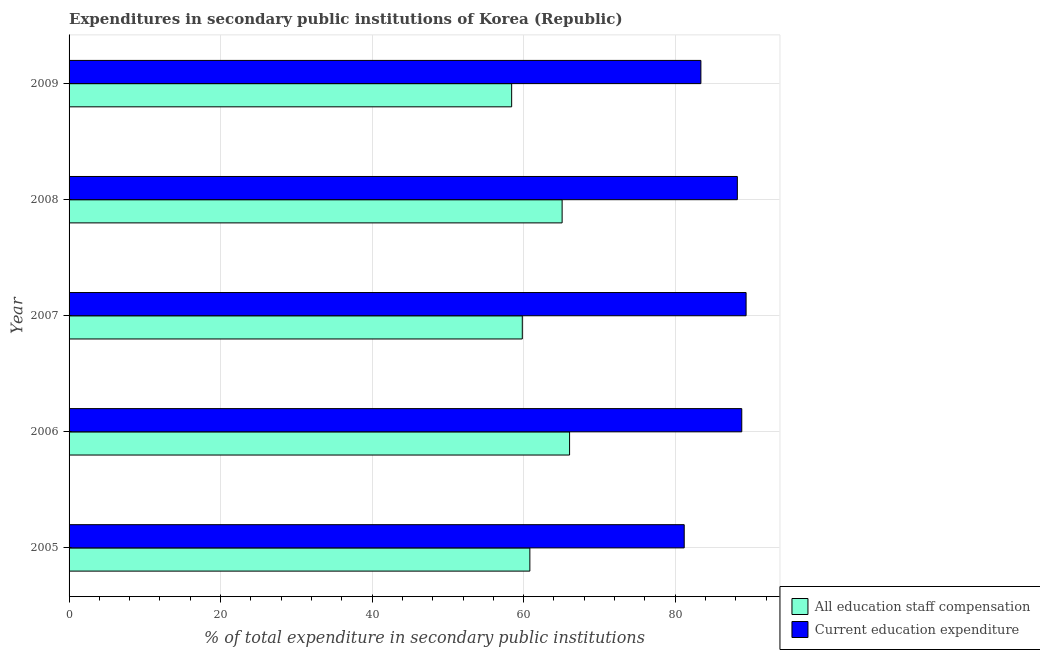Are the number of bars on each tick of the Y-axis equal?
Make the answer very short. Yes. How many bars are there on the 4th tick from the top?
Make the answer very short. 2. How many bars are there on the 1st tick from the bottom?
Your answer should be compact. 2. What is the label of the 5th group of bars from the top?
Provide a succinct answer. 2005. What is the expenditure in education in 2008?
Your answer should be very brief. 88.2. Across all years, what is the maximum expenditure in staff compensation?
Give a very brief answer. 66.06. Across all years, what is the minimum expenditure in education?
Your response must be concise. 81.19. What is the total expenditure in staff compensation in the graph?
Offer a terse response. 310.19. What is the difference between the expenditure in education in 2007 and that in 2008?
Your response must be concise. 1.15. What is the difference between the expenditure in education in 2008 and the expenditure in staff compensation in 2009?
Give a very brief answer. 29.79. What is the average expenditure in staff compensation per year?
Your answer should be very brief. 62.04. In the year 2009, what is the difference between the expenditure in staff compensation and expenditure in education?
Provide a short and direct response. -24.98. In how many years, is the expenditure in education greater than 32 %?
Provide a succinct answer. 5. What is the ratio of the expenditure in education in 2008 to that in 2009?
Keep it short and to the point. 1.06. Is the expenditure in education in 2005 less than that in 2006?
Provide a short and direct response. Yes. Is the difference between the expenditure in education in 2007 and 2009 greater than the difference between the expenditure in staff compensation in 2007 and 2009?
Give a very brief answer. Yes. What is the difference between the highest and the lowest expenditure in education?
Ensure brevity in your answer.  8.17. What does the 1st bar from the top in 2008 represents?
Offer a terse response. Current education expenditure. What does the 1st bar from the bottom in 2005 represents?
Offer a very short reply. All education staff compensation. How many bars are there?
Offer a terse response. 10. Are all the bars in the graph horizontal?
Provide a succinct answer. Yes. What is the difference between two consecutive major ticks on the X-axis?
Your answer should be very brief. 20. Does the graph contain any zero values?
Offer a terse response. No. Where does the legend appear in the graph?
Offer a terse response. Bottom right. What is the title of the graph?
Provide a short and direct response. Expenditures in secondary public institutions of Korea (Republic). What is the label or title of the X-axis?
Provide a short and direct response. % of total expenditure in secondary public institutions. What is the % of total expenditure in secondary public institutions of All education staff compensation in 2005?
Give a very brief answer. 60.82. What is the % of total expenditure in secondary public institutions in Current education expenditure in 2005?
Ensure brevity in your answer.  81.19. What is the % of total expenditure in secondary public institutions of All education staff compensation in 2006?
Ensure brevity in your answer.  66.06. What is the % of total expenditure in secondary public institutions of Current education expenditure in 2006?
Your response must be concise. 88.79. What is the % of total expenditure in secondary public institutions in All education staff compensation in 2007?
Your response must be concise. 59.82. What is the % of total expenditure in secondary public institutions in Current education expenditure in 2007?
Ensure brevity in your answer.  89.36. What is the % of total expenditure in secondary public institutions of All education staff compensation in 2008?
Offer a very short reply. 65.08. What is the % of total expenditure in secondary public institutions of Current education expenditure in 2008?
Provide a short and direct response. 88.2. What is the % of total expenditure in secondary public institutions in All education staff compensation in 2009?
Offer a very short reply. 58.42. What is the % of total expenditure in secondary public institutions in Current education expenditure in 2009?
Your response must be concise. 83.39. Across all years, what is the maximum % of total expenditure in secondary public institutions in All education staff compensation?
Provide a short and direct response. 66.06. Across all years, what is the maximum % of total expenditure in secondary public institutions in Current education expenditure?
Your answer should be compact. 89.36. Across all years, what is the minimum % of total expenditure in secondary public institutions of All education staff compensation?
Give a very brief answer. 58.42. Across all years, what is the minimum % of total expenditure in secondary public institutions in Current education expenditure?
Provide a short and direct response. 81.19. What is the total % of total expenditure in secondary public institutions in All education staff compensation in the graph?
Your answer should be compact. 310.19. What is the total % of total expenditure in secondary public institutions of Current education expenditure in the graph?
Offer a terse response. 430.93. What is the difference between the % of total expenditure in secondary public institutions of All education staff compensation in 2005 and that in 2006?
Keep it short and to the point. -5.24. What is the difference between the % of total expenditure in secondary public institutions in Current education expenditure in 2005 and that in 2006?
Ensure brevity in your answer.  -7.6. What is the difference between the % of total expenditure in secondary public institutions in All education staff compensation in 2005 and that in 2007?
Provide a short and direct response. 1. What is the difference between the % of total expenditure in secondary public institutions in Current education expenditure in 2005 and that in 2007?
Offer a terse response. -8.17. What is the difference between the % of total expenditure in secondary public institutions of All education staff compensation in 2005 and that in 2008?
Ensure brevity in your answer.  -4.26. What is the difference between the % of total expenditure in secondary public institutions in Current education expenditure in 2005 and that in 2008?
Make the answer very short. -7.01. What is the difference between the % of total expenditure in secondary public institutions in All education staff compensation in 2005 and that in 2009?
Offer a terse response. 2.4. What is the difference between the % of total expenditure in secondary public institutions in Current education expenditure in 2005 and that in 2009?
Your answer should be compact. -2.2. What is the difference between the % of total expenditure in secondary public institutions in All education staff compensation in 2006 and that in 2007?
Your answer should be compact. 6.24. What is the difference between the % of total expenditure in secondary public institutions in Current education expenditure in 2006 and that in 2007?
Provide a succinct answer. -0.57. What is the difference between the % of total expenditure in secondary public institutions of All education staff compensation in 2006 and that in 2008?
Offer a terse response. 0.98. What is the difference between the % of total expenditure in secondary public institutions in Current education expenditure in 2006 and that in 2008?
Provide a succinct answer. 0.58. What is the difference between the % of total expenditure in secondary public institutions of All education staff compensation in 2006 and that in 2009?
Your answer should be compact. 7.64. What is the difference between the % of total expenditure in secondary public institutions of Current education expenditure in 2006 and that in 2009?
Your answer should be compact. 5.4. What is the difference between the % of total expenditure in secondary public institutions in All education staff compensation in 2007 and that in 2008?
Make the answer very short. -5.26. What is the difference between the % of total expenditure in secondary public institutions in Current education expenditure in 2007 and that in 2008?
Ensure brevity in your answer.  1.15. What is the difference between the % of total expenditure in secondary public institutions in All education staff compensation in 2007 and that in 2009?
Keep it short and to the point. 1.4. What is the difference between the % of total expenditure in secondary public institutions of Current education expenditure in 2007 and that in 2009?
Ensure brevity in your answer.  5.97. What is the difference between the % of total expenditure in secondary public institutions in All education staff compensation in 2008 and that in 2009?
Offer a terse response. 6.66. What is the difference between the % of total expenditure in secondary public institutions in Current education expenditure in 2008 and that in 2009?
Ensure brevity in your answer.  4.81. What is the difference between the % of total expenditure in secondary public institutions in All education staff compensation in 2005 and the % of total expenditure in secondary public institutions in Current education expenditure in 2006?
Provide a short and direct response. -27.97. What is the difference between the % of total expenditure in secondary public institutions in All education staff compensation in 2005 and the % of total expenditure in secondary public institutions in Current education expenditure in 2007?
Offer a very short reply. -28.54. What is the difference between the % of total expenditure in secondary public institutions in All education staff compensation in 2005 and the % of total expenditure in secondary public institutions in Current education expenditure in 2008?
Make the answer very short. -27.39. What is the difference between the % of total expenditure in secondary public institutions of All education staff compensation in 2005 and the % of total expenditure in secondary public institutions of Current education expenditure in 2009?
Offer a terse response. -22.57. What is the difference between the % of total expenditure in secondary public institutions of All education staff compensation in 2006 and the % of total expenditure in secondary public institutions of Current education expenditure in 2007?
Your answer should be very brief. -23.3. What is the difference between the % of total expenditure in secondary public institutions of All education staff compensation in 2006 and the % of total expenditure in secondary public institutions of Current education expenditure in 2008?
Offer a very short reply. -22.14. What is the difference between the % of total expenditure in secondary public institutions in All education staff compensation in 2006 and the % of total expenditure in secondary public institutions in Current education expenditure in 2009?
Your answer should be compact. -17.33. What is the difference between the % of total expenditure in secondary public institutions of All education staff compensation in 2007 and the % of total expenditure in secondary public institutions of Current education expenditure in 2008?
Provide a succinct answer. -28.38. What is the difference between the % of total expenditure in secondary public institutions in All education staff compensation in 2007 and the % of total expenditure in secondary public institutions in Current education expenditure in 2009?
Make the answer very short. -23.57. What is the difference between the % of total expenditure in secondary public institutions of All education staff compensation in 2008 and the % of total expenditure in secondary public institutions of Current education expenditure in 2009?
Make the answer very short. -18.32. What is the average % of total expenditure in secondary public institutions of All education staff compensation per year?
Your answer should be compact. 62.04. What is the average % of total expenditure in secondary public institutions of Current education expenditure per year?
Your response must be concise. 86.19. In the year 2005, what is the difference between the % of total expenditure in secondary public institutions in All education staff compensation and % of total expenditure in secondary public institutions in Current education expenditure?
Your response must be concise. -20.37. In the year 2006, what is the difference between the % of total expenditure in secondary public institutions of All education staff compensation and % of total expenditure in secondary public institutions of Current education expenditure?
Provide a short and direct response. -22.73. In the year 2007, what is the difference between the % of total expenditure in secondary public institutions in All education staff compensation and % of total expenditure in secondary public institutions in Current education expenditure?
Offer a terse response. -29.54. In the year 2008, what is the difference between the % of total expenditure in secondary public institutions in All education staff compensation and % of total expenditure in secondary public institutions in Current education expenditure?
Offer a terse response. -23.13. In the year 2009, what is the difference between the % of total expenditure in secondary public institutions of All education staff compensation and % of total expenditure in secondary public institutions of Current education expenditure?
Offer a terse response. -24.98. What is the ratio of the % of total expenditure in secondary public institutions in All education staff compensation in 2005 to that in 2006?
Provide a succinct answer. 0.92. What is the ratio of the % of total expenditure in secondary public institutions of Current education expenditure in 2005 to that in 2006?
Your answer should be very brief. 0.91. What is the ratio of the % of total expenditure in secondary public institutions in All education staff compensation in 2005 to that in 2007?
Give a very brief answer. 1.02. What is the ratio of the % of total expenditure in secondary public institutions in Current education expenditure in 2005 to that in 2007?
Offer a very short reply. 0.91. What is the ratio of the % of total expenditure in secondary public institutions in All education staff compensation in 2005 to that in 2008?
Your response must be concise. 0.93. What is the ratio of the % of total expenditure in secondary public institutions of Current education expenditure in 2005 to that in 2008?
Give a very brief answer. 0.92. What is the ratio of the % of total expenditure in secondary public institutions of All education staff compensation in 2005 to that in 2009?
Offer a terse response. 1.04. What is the ratio of the % of total expenditure in secondary public institutions of Current education expenditure in 2005 to that in 2009?
Offer a very short reply. 0.97. What is the ratio of the % of total expenditure in secondary public institutions of All education staff compensation in 2006 to that in 2007?
Provide a succinct answer. 1.1. What is the ratio of the % of total expenditure in secondary public institutions in All education staff compensation in 2006 to that in 2008?
Keep it short and to the point. 1.02. What is the ratio of the % of total expenditure in secondary public institutions in Current education expenditure in 2006 to that in 2008?
Provide a succinct answer. 1.01. What is the ratio of the % of total expenditure in secondary public institutions of All education staff compensation in 2006 to that in 2009?
Make the answer very short. 1.13. What is the ratio of the % of total expenditure in secondary public institutions in Current education expenditure in 2006 to that in 2009?
Keep it short and to the point. 1.06. What is the ratio of the % of total expenditure in secondary public institutions of All education staff compensation in 2007 to that in 2008?
Make the answer very short. 0.92. What is the ratio of the % of total expenditure in secondary public institutions in Current education expenditure in 2007 to that in 2008?
Provide a short and direct response. 1.01. What is the ratio of the % of total expenditure in secondary public institutions in All education staff compensation in 2007 to that in 2009?
Offer a terse response. 1.02. What is the ratio of the % of total expenditure in secondary public institutions of Current education expenditure in 2007 to that in 2009?
Your answer should be very brief. 1.07. What is the ratio of the % of total expenditure in secondary public institutions of All education staff compensation in 2008 to that in 2009?
Provide a succinct answer. 1.11. What is the ratio of the % of total expenditure in secondary public institutions in Current education expenditure in 2008 to that in 2009?
Make the answer very short. 1.06. What is the difference between the highest and the second highest % of total expenditure in secondary public institutions of All education staff compensation?
Your answer should be compact. 0.98. What is the difference between the highest and the second highest % of total expenditure in secondary public institutions in Current education expenditure?
Keep it short and to the point. 0.57. What is the difference between the highest and the lowest % of total expenditure in secondary public institutions of All education staff compensation?
Your answer should be very brief. 7.64. What is the difference between the highest and the lowest % of total expenditure in secondary public institutions of Current education expenditure?
Offer a very short reply. 8.17. 